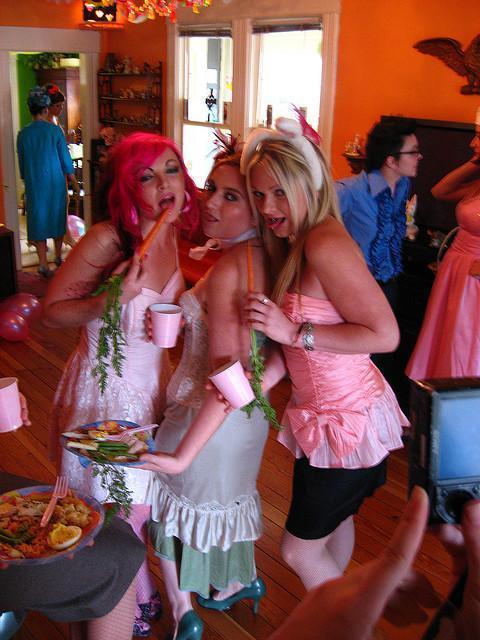How many people are there?
Give a very brief answer. 8. How many cares are to the left of the bike rider?
Give a very brief answer. 0. 